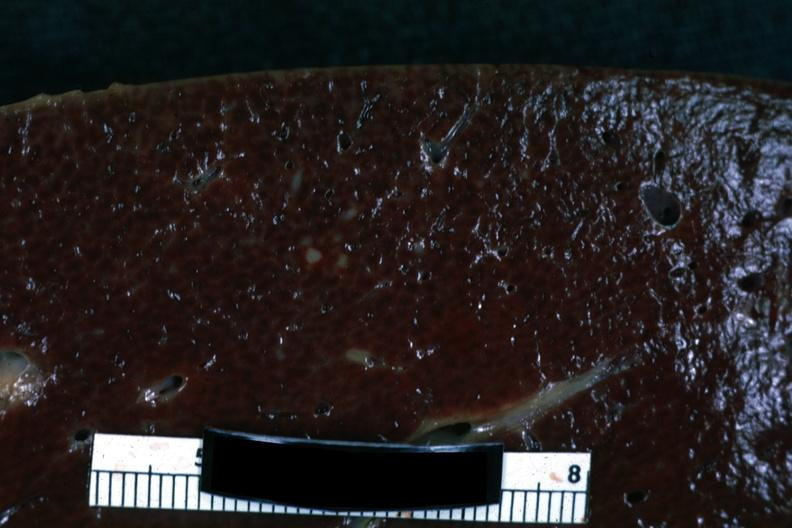what is present?
Answer the question using a single word or phrase. Spleen 